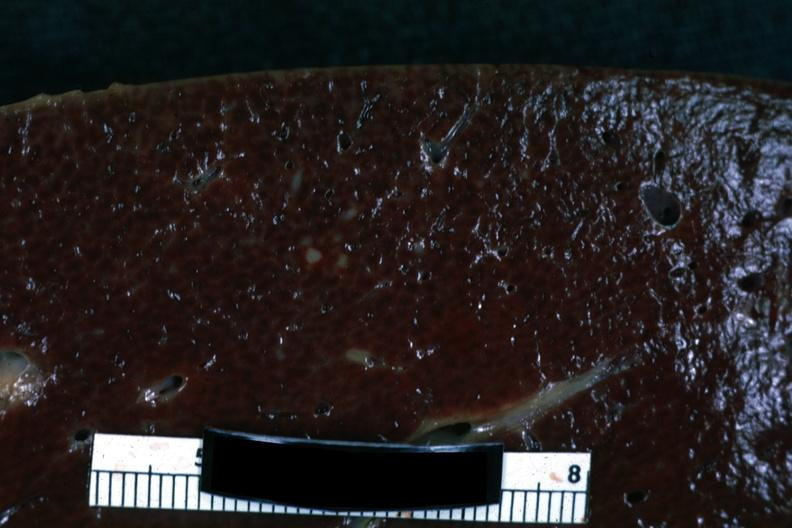what is present?
Answer the question using a single word or phrase. Spleen 